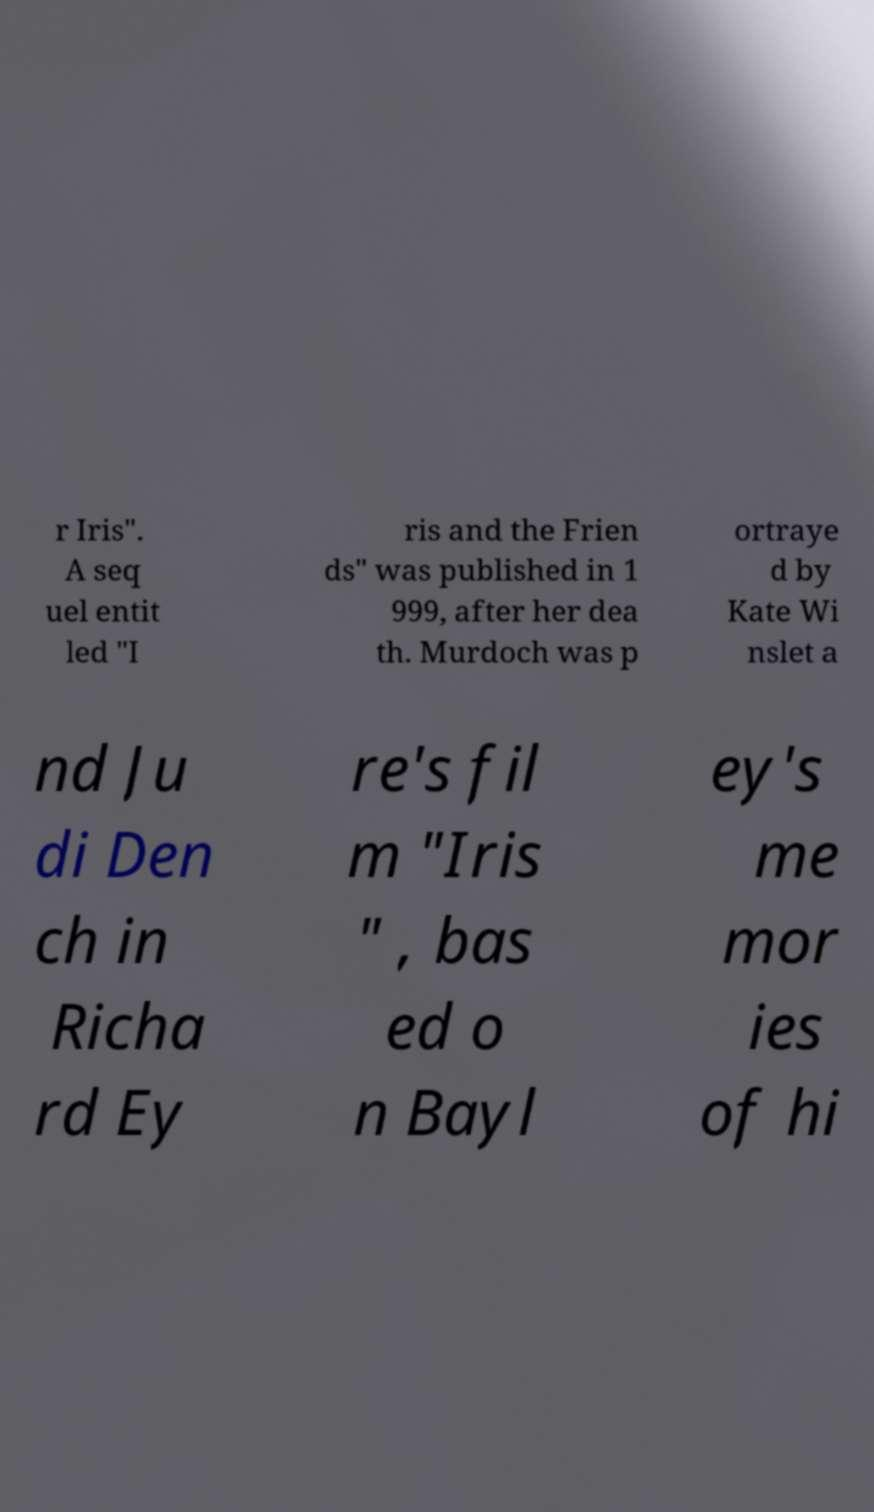I need the written content from this picture converted into text. Can you do that? r Iris". A seq uel entit led "I ris and the Frien ds" was published in 1 999, after her dea th. Murdoch was p ortraye d by Kate Wi nslet a nd Ju di Den ch in Richa rd Ey re's fil m "Iris " , bas ed o n Bayl ey's me mor ies of hi 